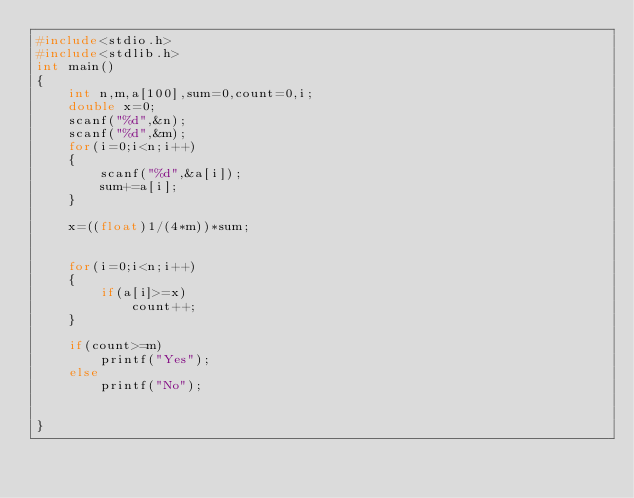<code> <loc_0><loc_0><loc_500><loc_500><_C_>#include<stdio.h>
#include<stdlib.h>
int main()
{
    int n,m,a[100],sum=0,count=0,i;
    double x=0;
    scanf("%d",&n);
    scanf("%d",&m);
    for(i=0;i<n;i++)
    {
        scanf("%d",&a[i]);
        sum+=a[i];
    }
    
    x=((float)1/(4*m))*sum;
    
    
    for(i=0;i<n;i++)
    {
        if(a[i]>=x)
            count++;
    }
    
    if(count>=m)
        printf("Yes");
    else
        printf("No");
    
    
}</code> 